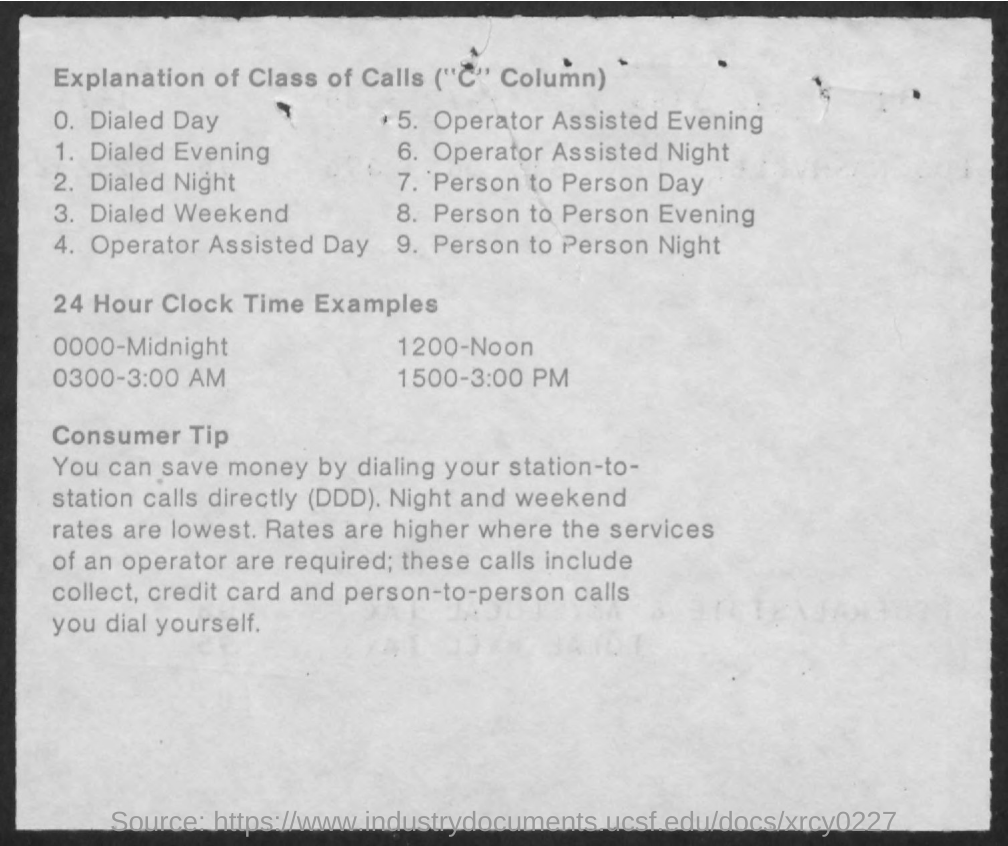Highlight a few significant elements in this photo. 0300 in the 24-hour clock, as represented on the page, represents 3:00 AM. 1200 in the 24-hour clock format refers to noon. The phrase "what does 1500 represents in the 24 hour clock as shown in the given page ? 3:00 PM.." is asking for an explanation of what the representation of 1500 in the 24 hour clock means in the context of the given page. The 24-hour clock, as shown on the given page, represents midnight as 0000. 